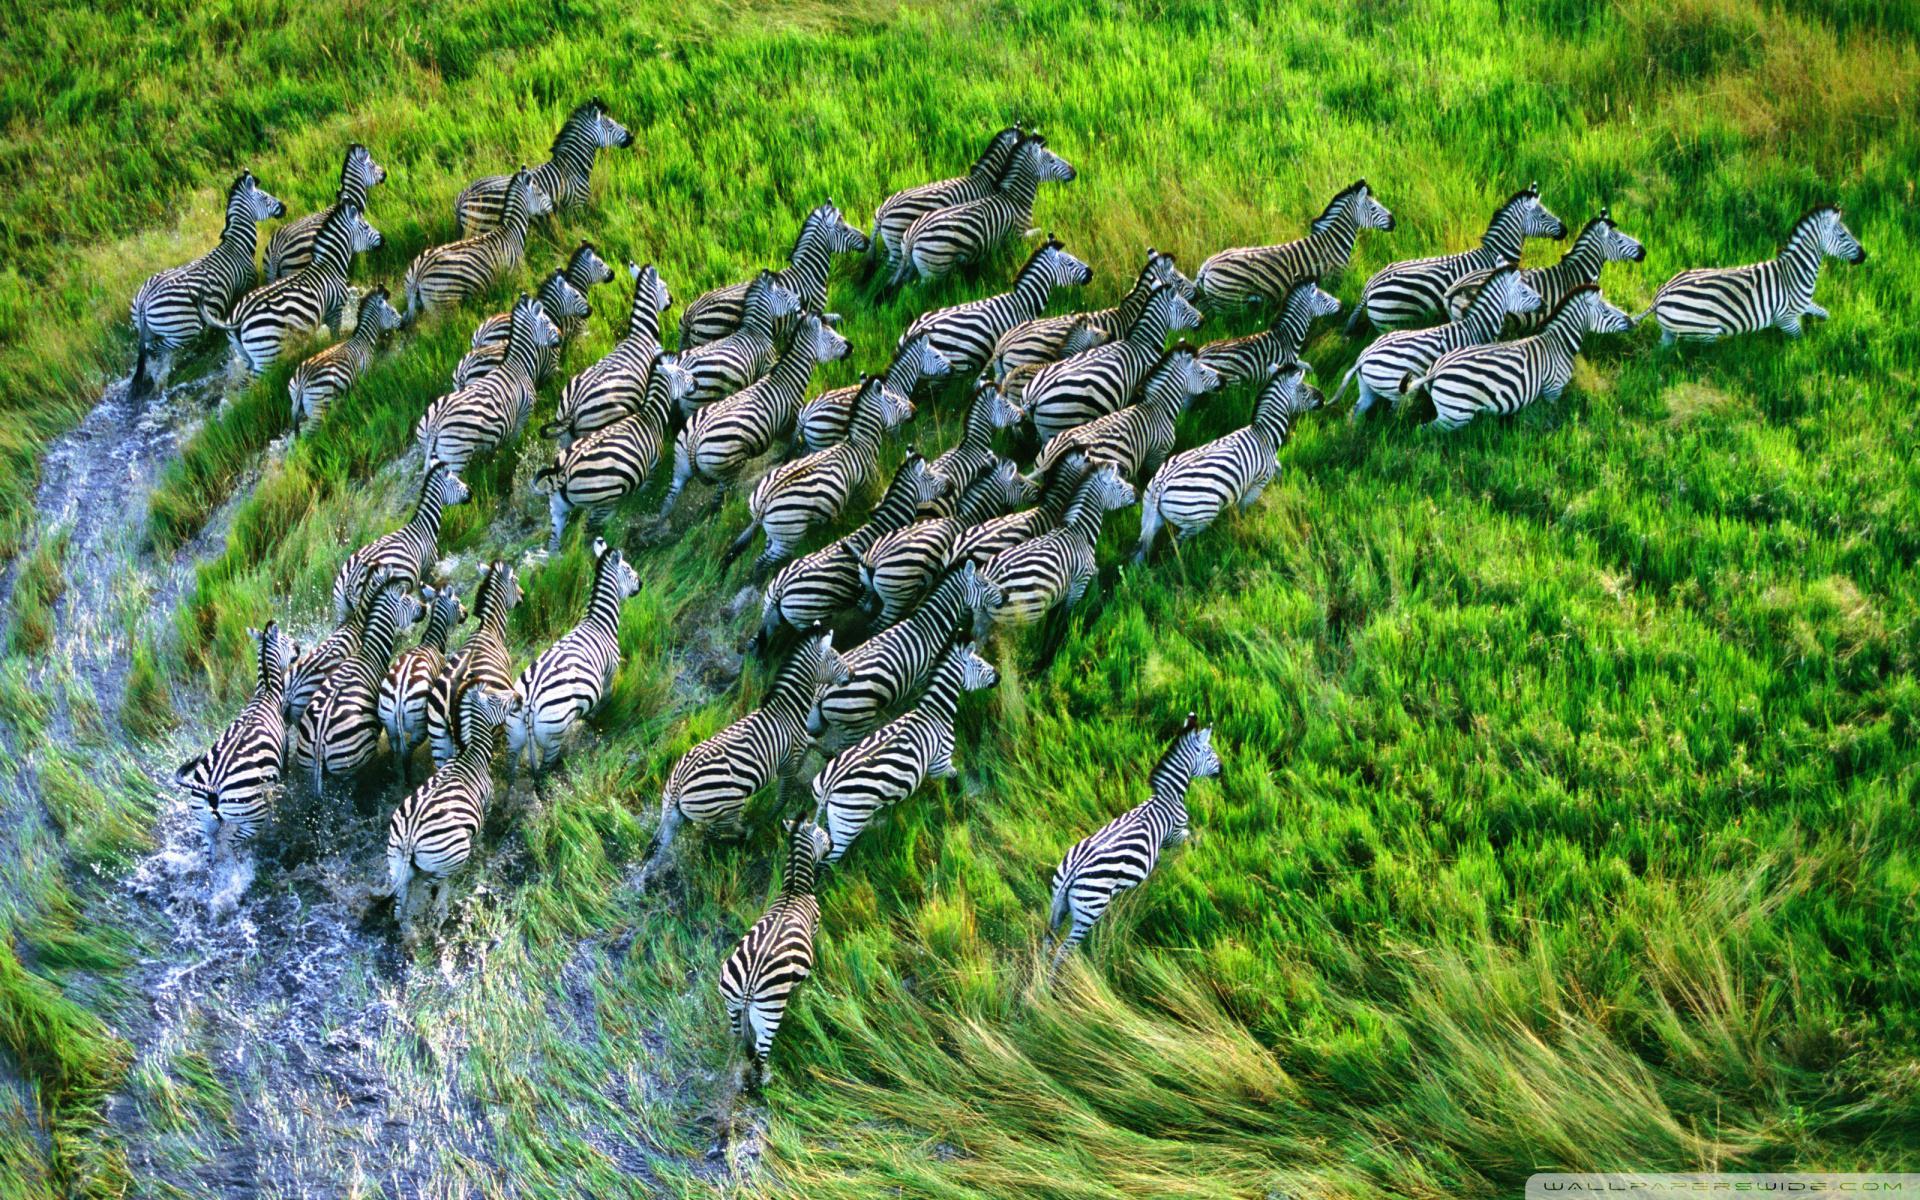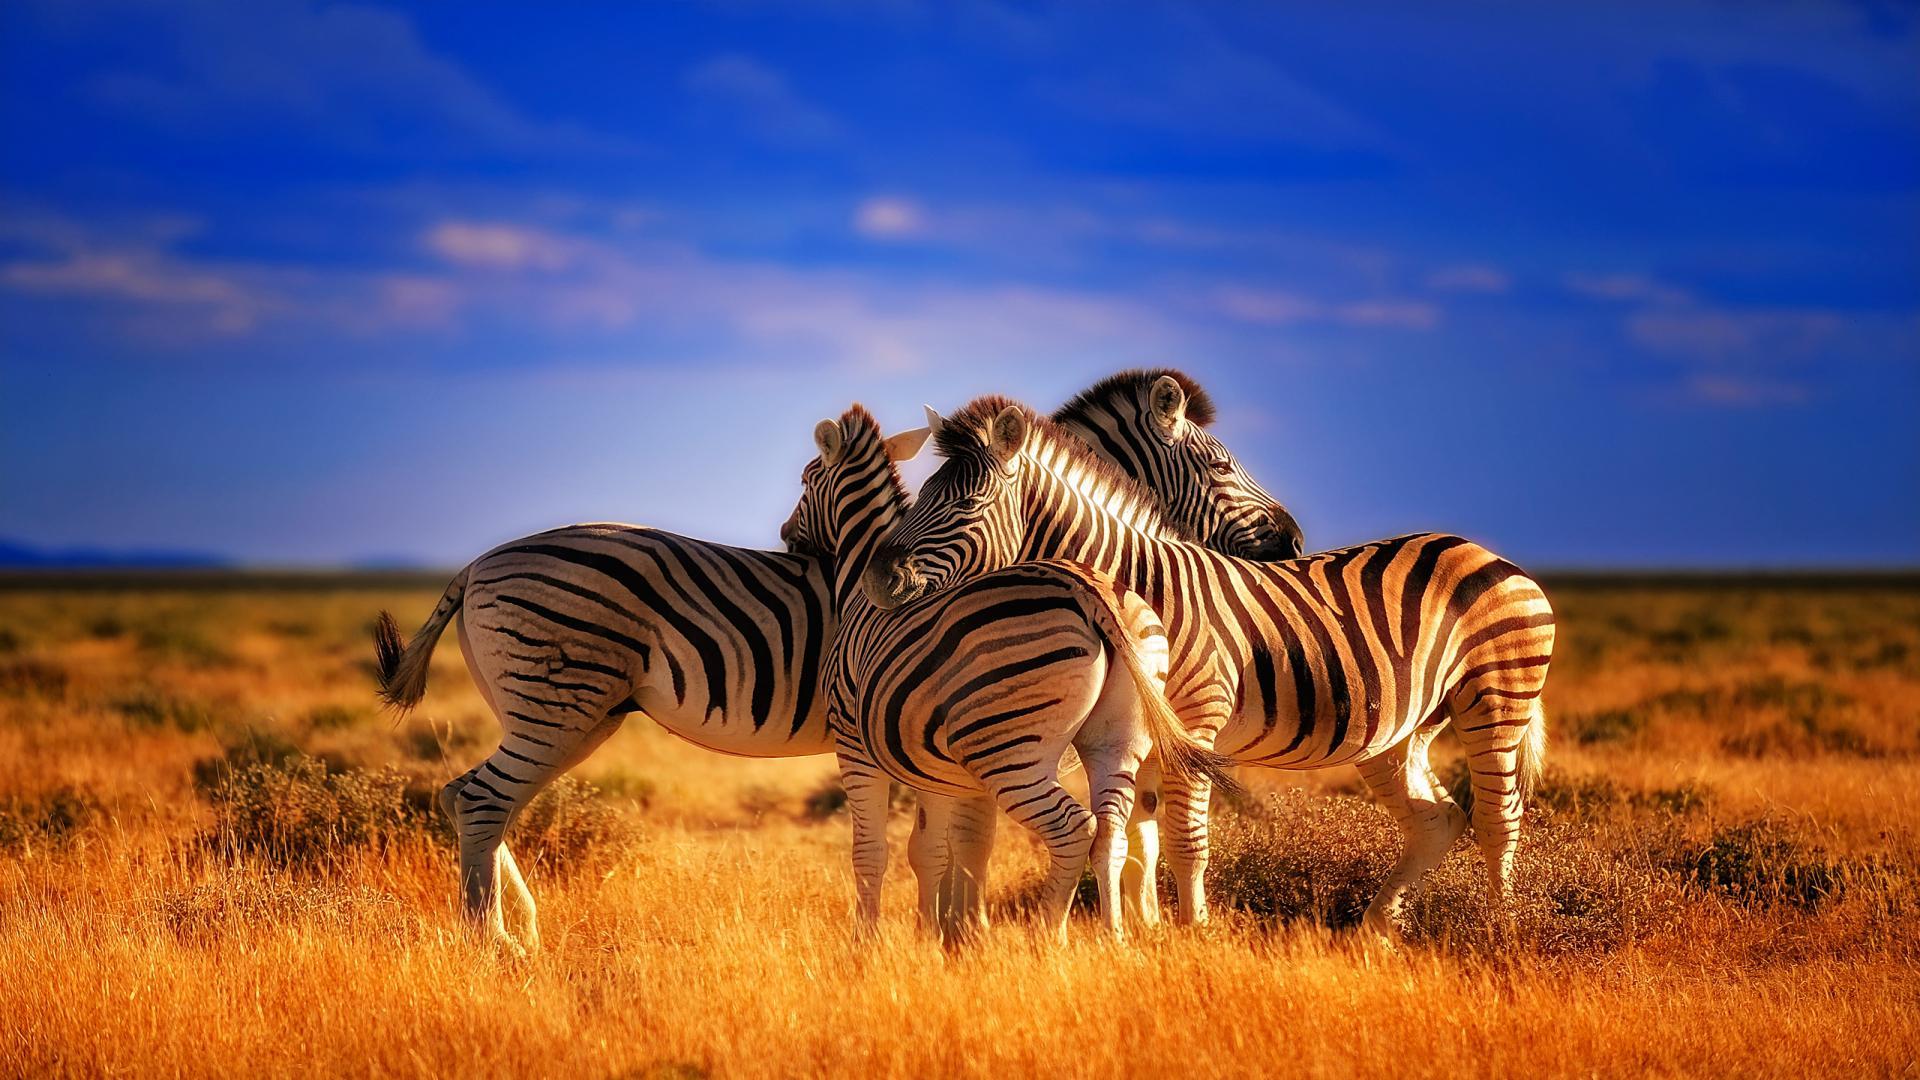The first image is the image on the left, the second image is the image on the right. Examine the images to the left and right. Is the description "The right image contains no more than two zebras." accurate? Answer yes or no. No. The first image is the image on the left, the second image is the image on the right. Given the left and right images, does the statement "Exactly one zebra is grazing." hold true? Answer yes or no. No. 